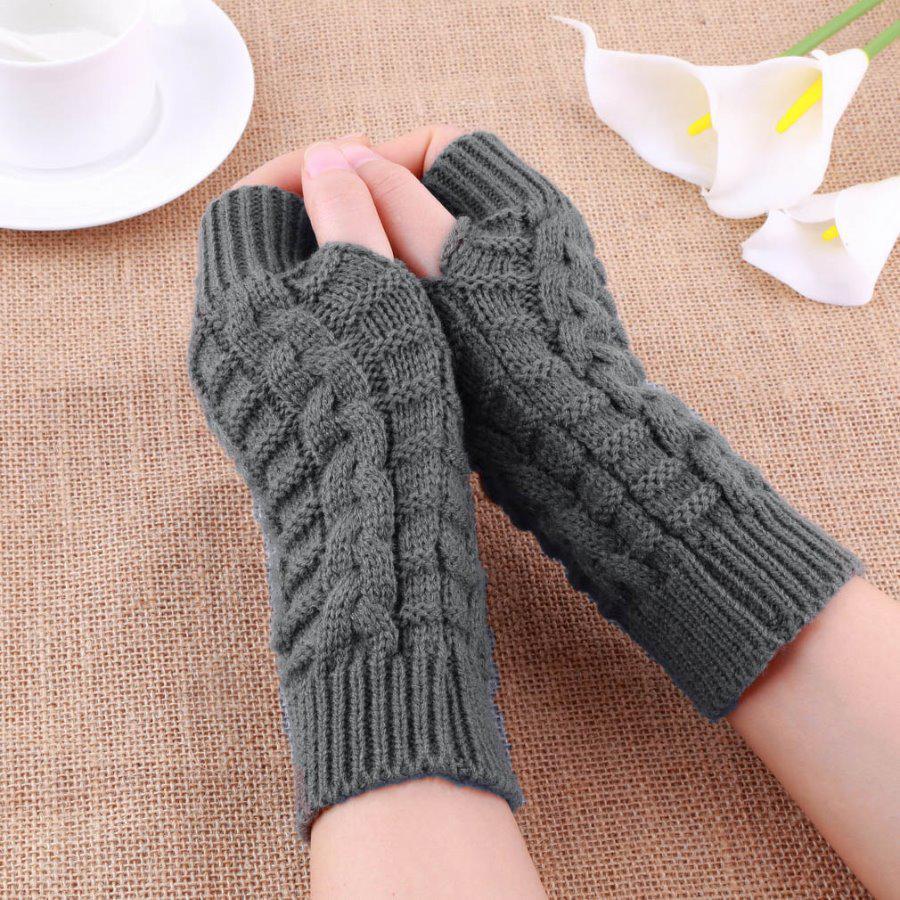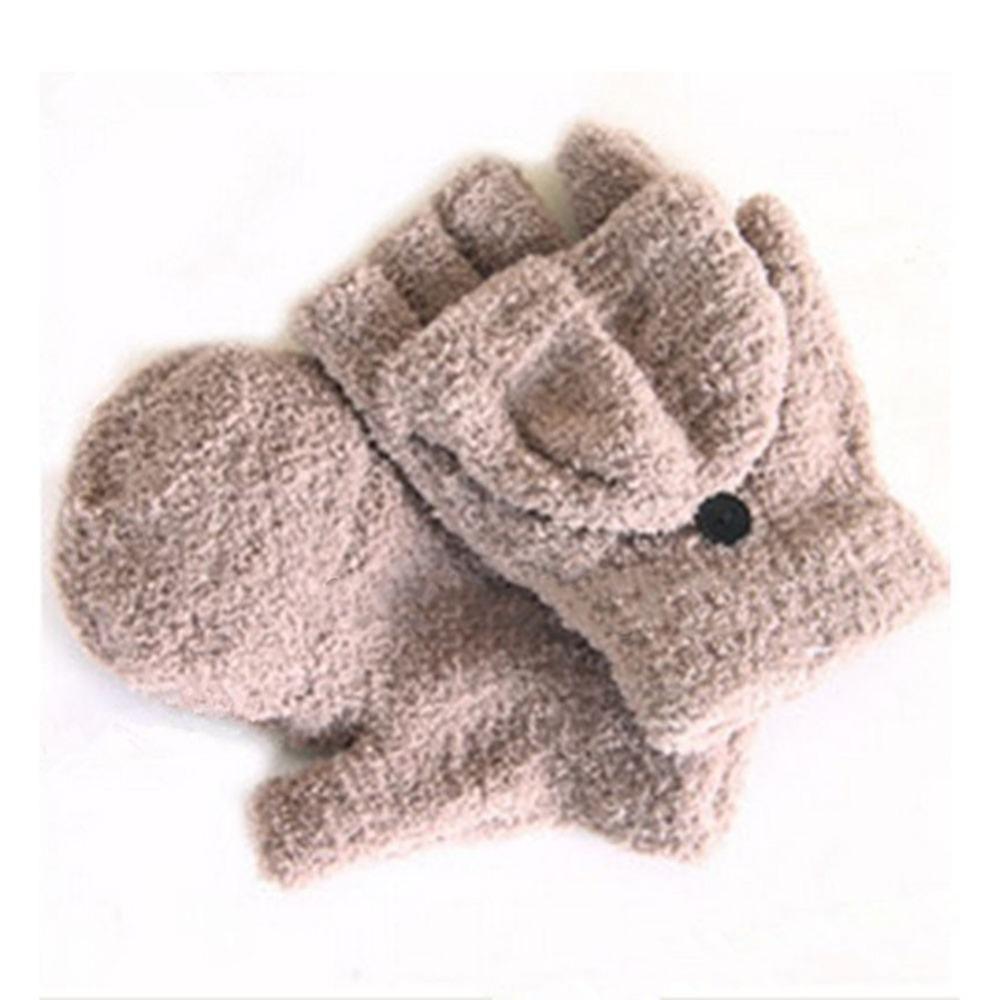The first image is the image on the left, the second image is the image on the right. Analyze the images presented: Is the assertion "The gloves in one of the images is not being worn." valid? Answer yes or no. Yes. 